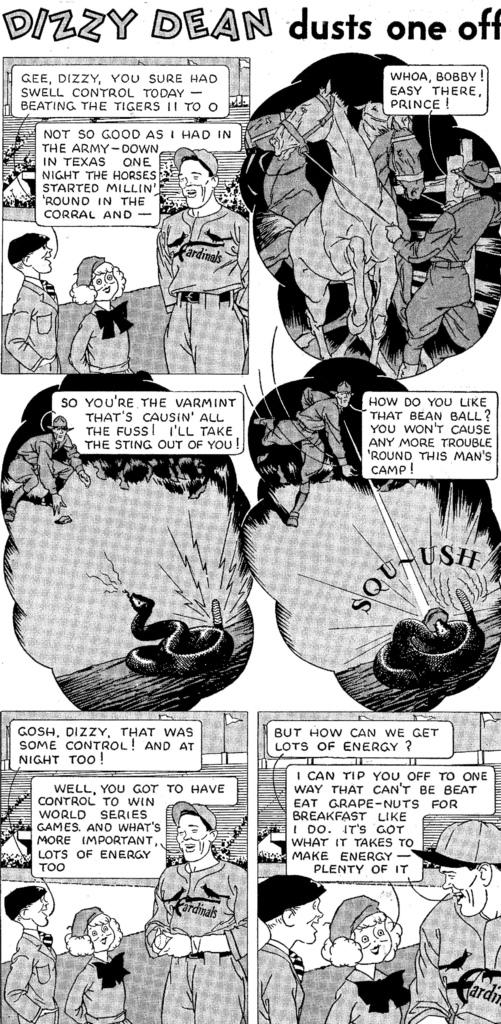What is the main subject of the image? The main subject of the image is a group of people. What animals are present in the image? There are horses in the image. Is there any text visible in the image? Yes, there is text in the image. What type of wildlife can be seen in the image? There are snakes in the image. What type of vegetation is present in the image? There are plants in the image. How long does it take for the snakes to run up the hill in the image? There is no hill present in the image, and snakes do not run. 